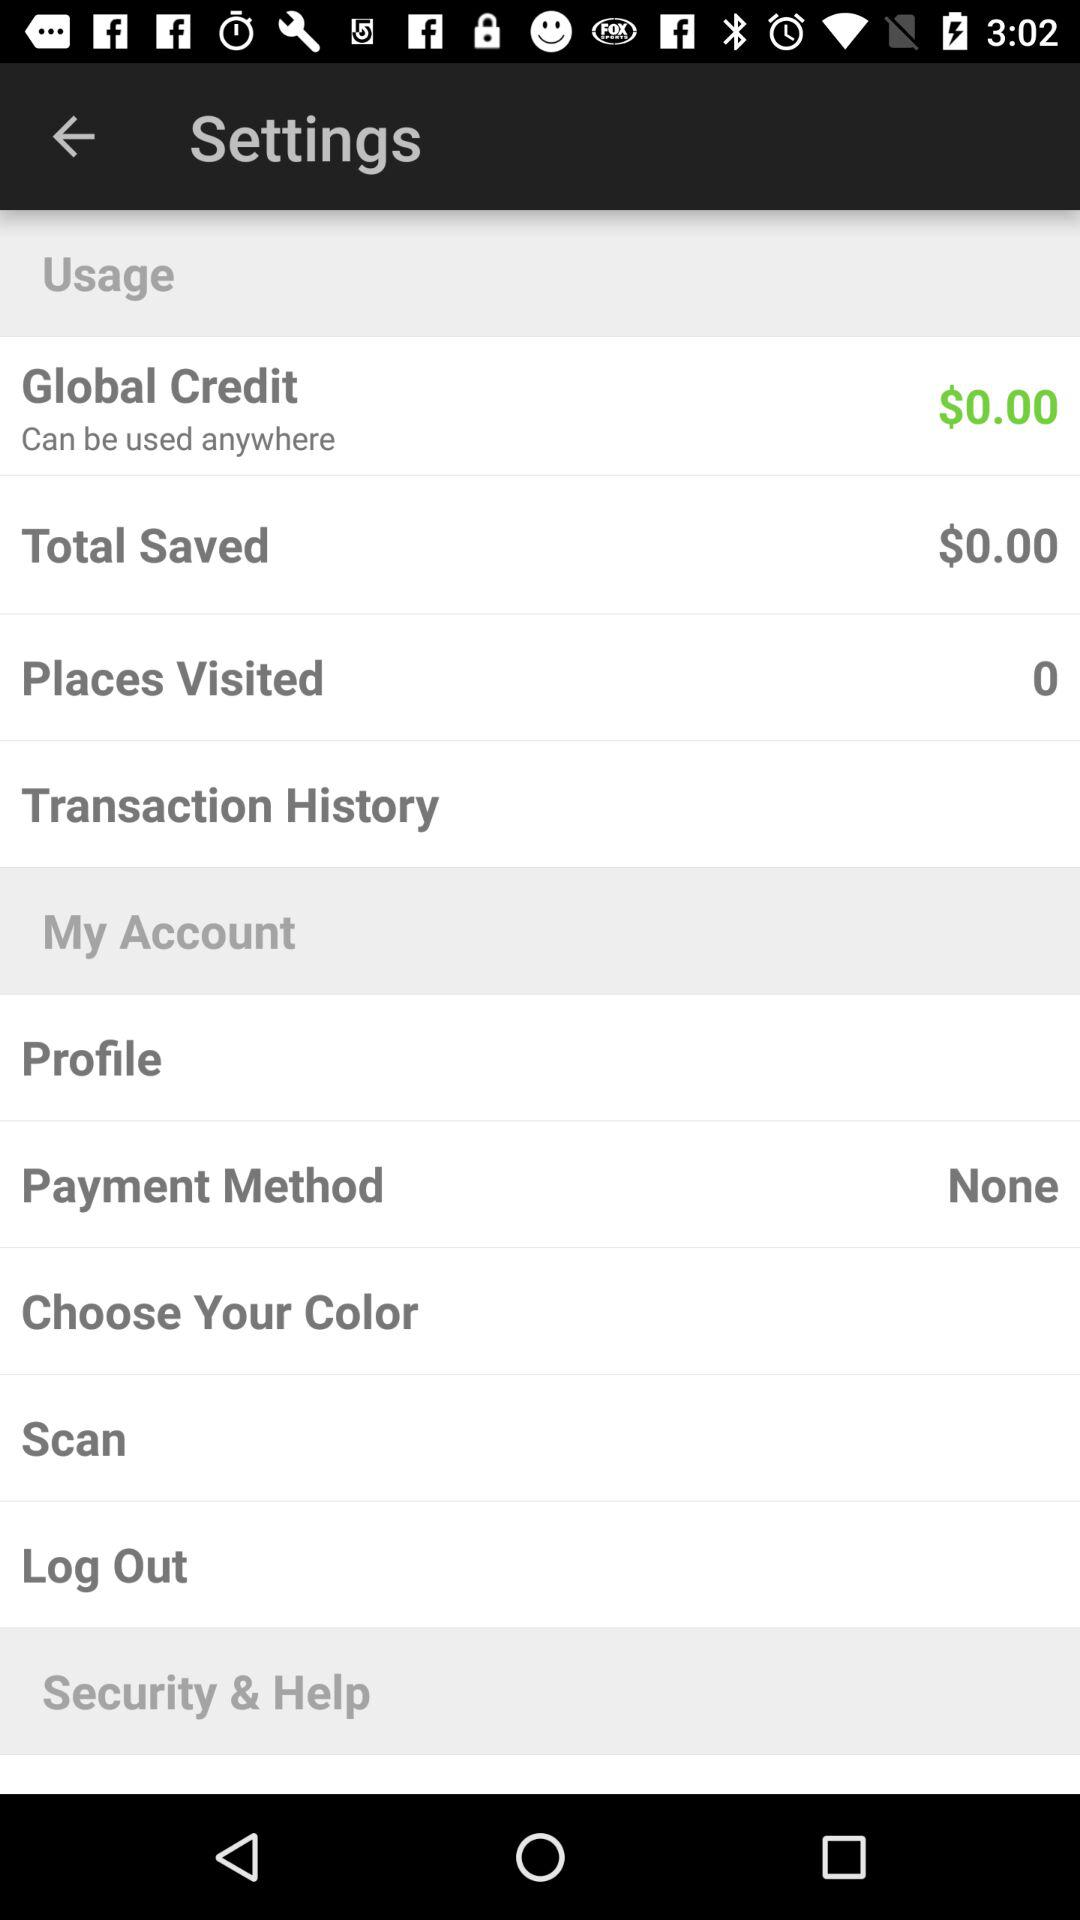How much money is there in "Global Credit"? There is $0.00 in "Global Credit". 